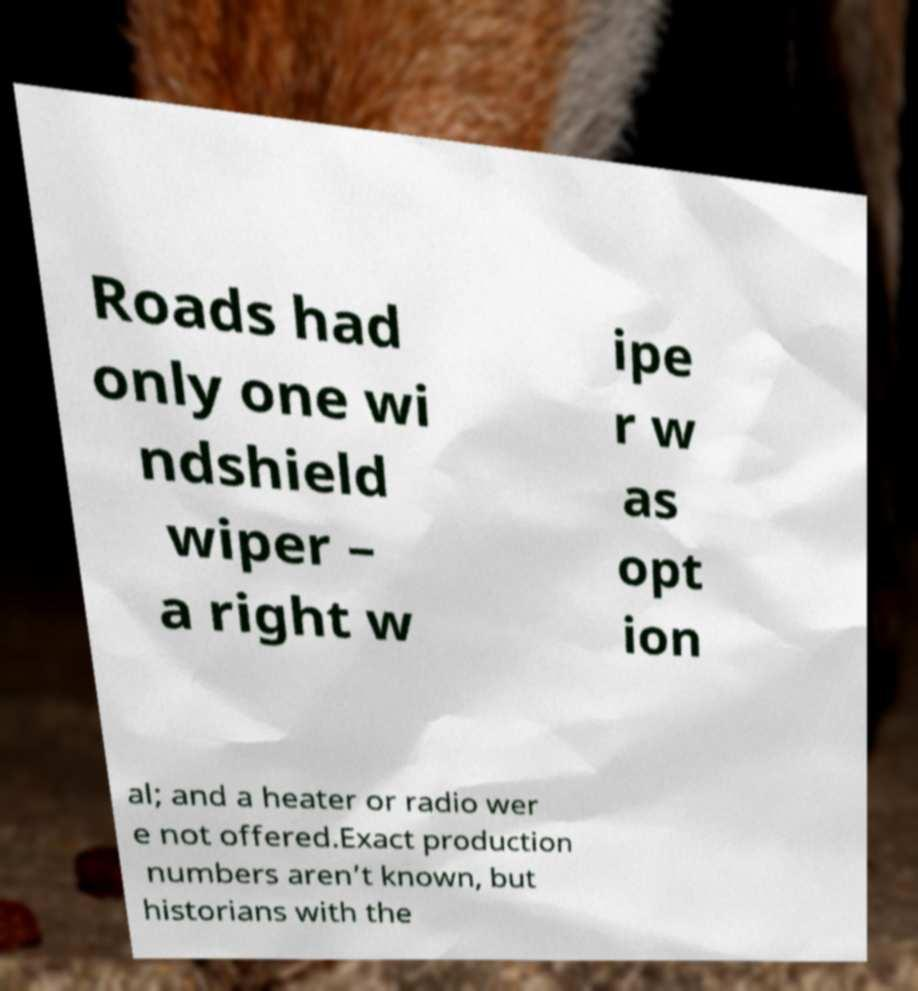Can you read and provide the text displayed in the image?This photo seems to have some interesting text. Can you extract and type it out for me? Roads had only one wi ndshield wiper – a right w ipe r w as opt ion al; and a heater or radio wer e not offered.Exact production numbers aren’t known, but historians with the 